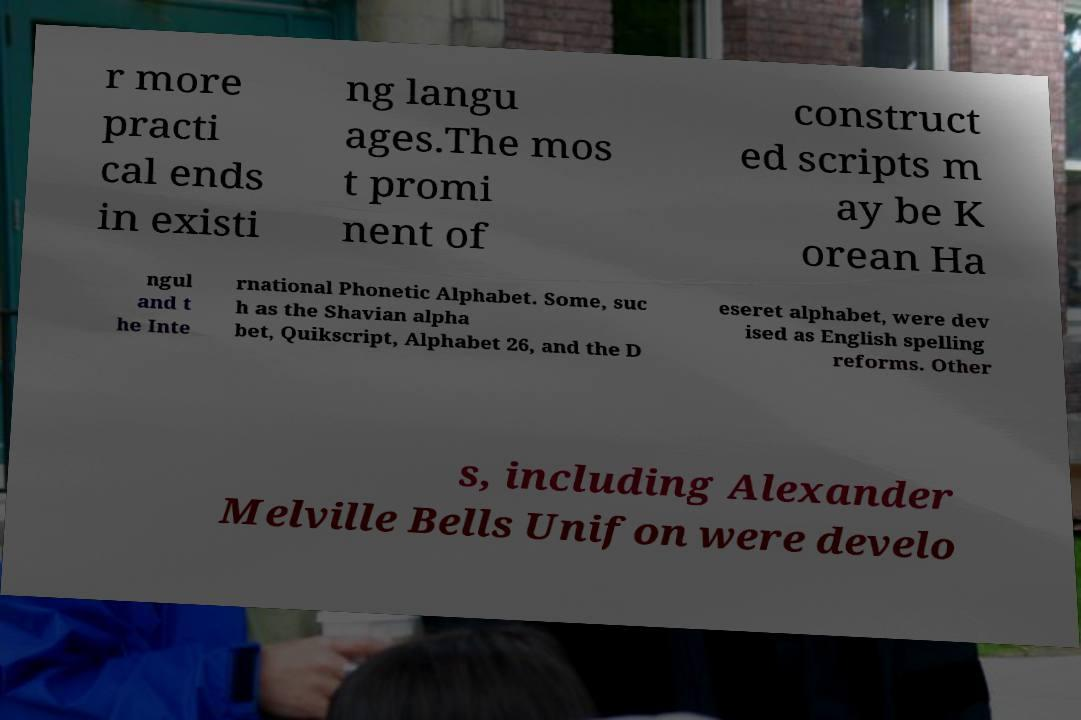Could you extract and type out the text from this image? r more practi cal ends in existi ng langu ages.The mos t promi nent of construct ed scripts m ay be K orean Ha ngul and t he Inte rnational Phonetic Alphabet. Some, suc h as the Shavian alpha bet, Quikscript, Alphabet 26, and the D eseret alphabet, were dev ised as English spelling reforms. Other s, including Alexander Melville Bells Unifon were develo 